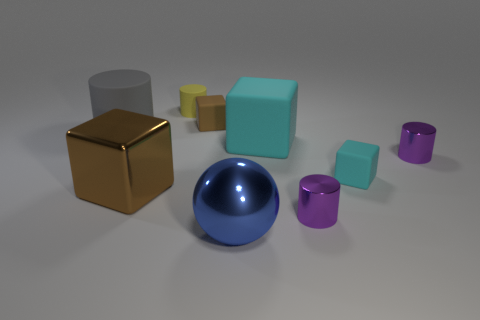There is a rubber block that is the same size as the gray cylinder; what color is it?
Give a very brief answer. Cyan. How many other objects have the same shape as the big brown metallic object?
Your response must be concise. 3. Is the size of the metallic block the same as the sphere that is right of the gray cylinder?
Ensure brevity in your answer.  Yes. There is a matte object that is to the right of the cyan object that is behind the small cyan rubber block; what shape is it?
Offer a terse response. Cube. Are there fewer large rubber cubes to the left of the big gray rubber cylinder than tiny purple balls?
Your answer should be compact. No. What number of gray matte objects are the same size as the yellow matte thing?
Your response must be concise. 0. The big brown thing left of the large blue metal thing has what shape?
Your answer should be compact. Cube. Is the number of big rubber blocks less than the number of tiny things?
Ensure brevity in your answer.  Yes. Is there any other thing that has the same color as the large ball?
Make the answer very short. No. There is a thing behind the brown rubber block; what size is it?
Keep it short and to the point. Small. 